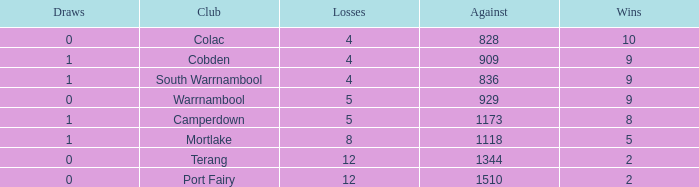What is the sum of losses for Against values over 1510? None. 